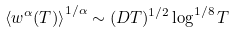<formula> <loc_0><loc_0><loc_500><loc_500>\left \langle w ^ { \alpha } ( T ) \right \rangle ^ { 1 / \alpha } \sim ( D T ) ^ { 1 / 2 } \log ^ { 1 / 8 } T</formula> 